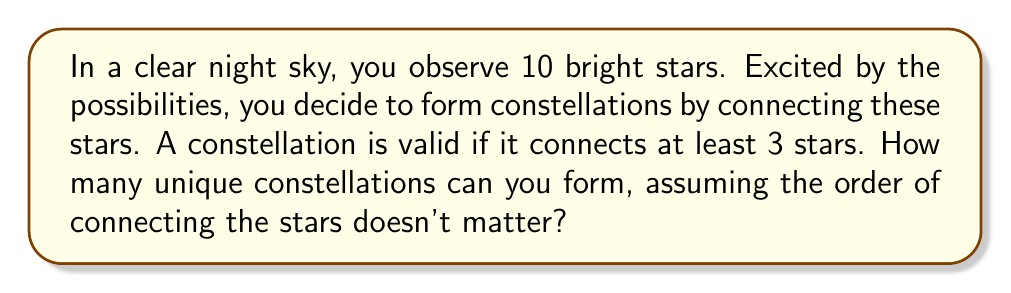What is the answer to this math problem? Let's approach this step-by-step:

1) First, we need to determine how many ways we can choose stars for our constellations:

   - We can choose 3 stars out of 10: $\binom{10}{3}$
   - We can choose 4 stars out of 10: $\binom{10}{4}$
   - ...
   - We can choose all 10 stars: $\binom{10}{10}$

2) For each of these choices, we need to count how many ways we can connect the stars to form a constellation. This is equivalent to counting the number of spanning trees in a complete graph with $n$ vertices, where $n$ is the number of stars chosen.

3) Cayley's formula states that the number of spanning trees in a complete graph with $n$ vertices is $n^{n-2}$.

4) Therefore, for each choice of $k$ stars $(3 \leq k \leq 10)$, we have $\binom{10}{k} \cdot k^{k-2}$ possible constellations.

5) The total number of constellations is the sum of all these possibilities:

   $$\sum_{k=3}^{10} \binom{10}{k} \cdot k^{k-2}$$

6) Let's calculate this sum:

   $\binom{10}{3} \cdot 3^1 + \binom{10}{4} \cdot 4^2 + \binom{10}{5} \cdot 5^3 + \binom{10}{6} \cdot 6^4 + \binom{10}{7} \cdot 7^5 + \binom{10}{8} \cdot 8^6 + \binom{10}{9} \cdot 9^7 + \binom{10}{10} \cdot 10^8$

   $= 120 \cdot 3 + 210 \cdot 16 + 252 \cdot 125 + 210 \cdot 1296 + 120 \cdot 16807 + 45 \cdot 262144 + 10 \cdot 4782969 + 1 \cdot 100000000$

   $= 360 + 3360 + 31500 + 272160 + 2016840 + 11796480 + 47829690 + 100000000$

   $= 161,950,390$

This enormous number of possibilities showcases the vast creativity of the universe!
Answer: 161,950,390 